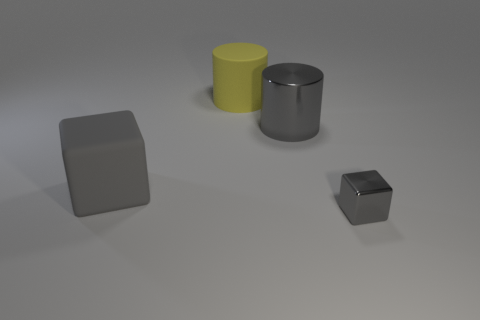Do the big yellow object left of the big metal cylinder and the tiny gray metal object have the same shape?
Provide a short and direct response. No. What color is the cylinder that is the same material as the tiny gray cube?
Offer a very short reply. Gray. There is a rubber thing that is behind the big gray cylinder that is on the right side of the yellow object; is there a thing to the left of it?
Offer a terse response. Yes. What shape is the large metallic thing?
Keep it short and to the point. Cylinder. Are there fewer large shiny cylinders in front of the big gray metallic cylinder than small red objects?
Your answer should be very brief. No. Is there a rubber object of the same shape as the big shiny thing?
Keep it short and to the point. Yes. What shape is the yellow rubber object that is the same size as the shiny cylinder?
Ensure brevity in your answer.  Cylinder. How many things are yellow matte things or small blocks?
Your answer should be compact. 2. Is there a big gray shiny cylinder?
Your answer should be very brief. Yes. Is the number of gray things less than the number of large gray metallic cylinders?
Provide a succinct answer. No. 